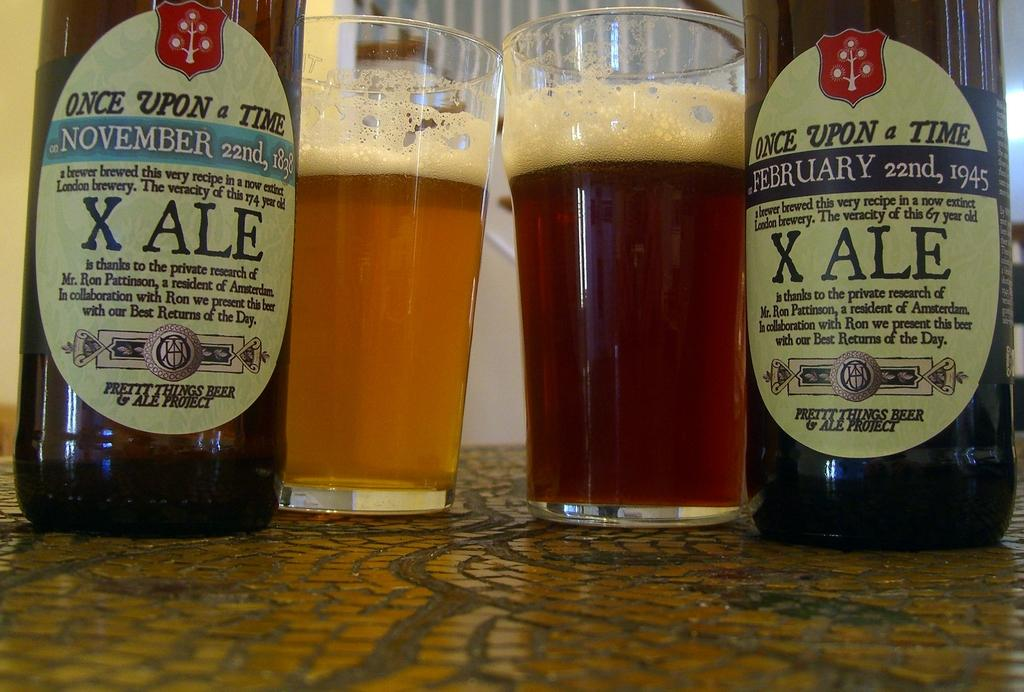<image>
Give a short and clear explanation of the subsequent image. Two types of X ALE beers are shown on a table next to beers in glasses. 